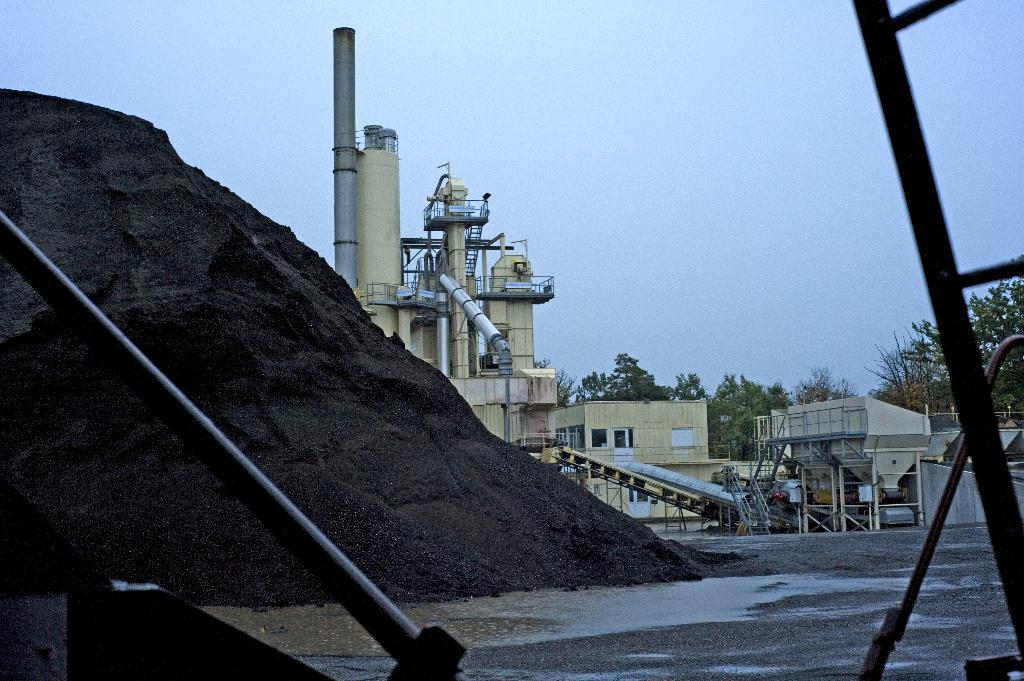What type of structures can be seen in the image? There are buildings in the image. What is the primary mode of transportation visible in the image? There is a road in the image. What natural element can be seen in the image? Water is visible in the image. What type of vegetation is present in the background of the image? There are trees in the background of the image. What part of the natural environment is visible in the image? The sky is visible in the background of the image. What color is the object that stands out in the image? There is a black-colored object in the image. What type of shirt is the writer wearing in the image? There is no writer or shirt present in the image. How does the toothbrush help clean the water in the image? There is no toothbrush present in the image, and therefore it cannot be used to clean the water. 